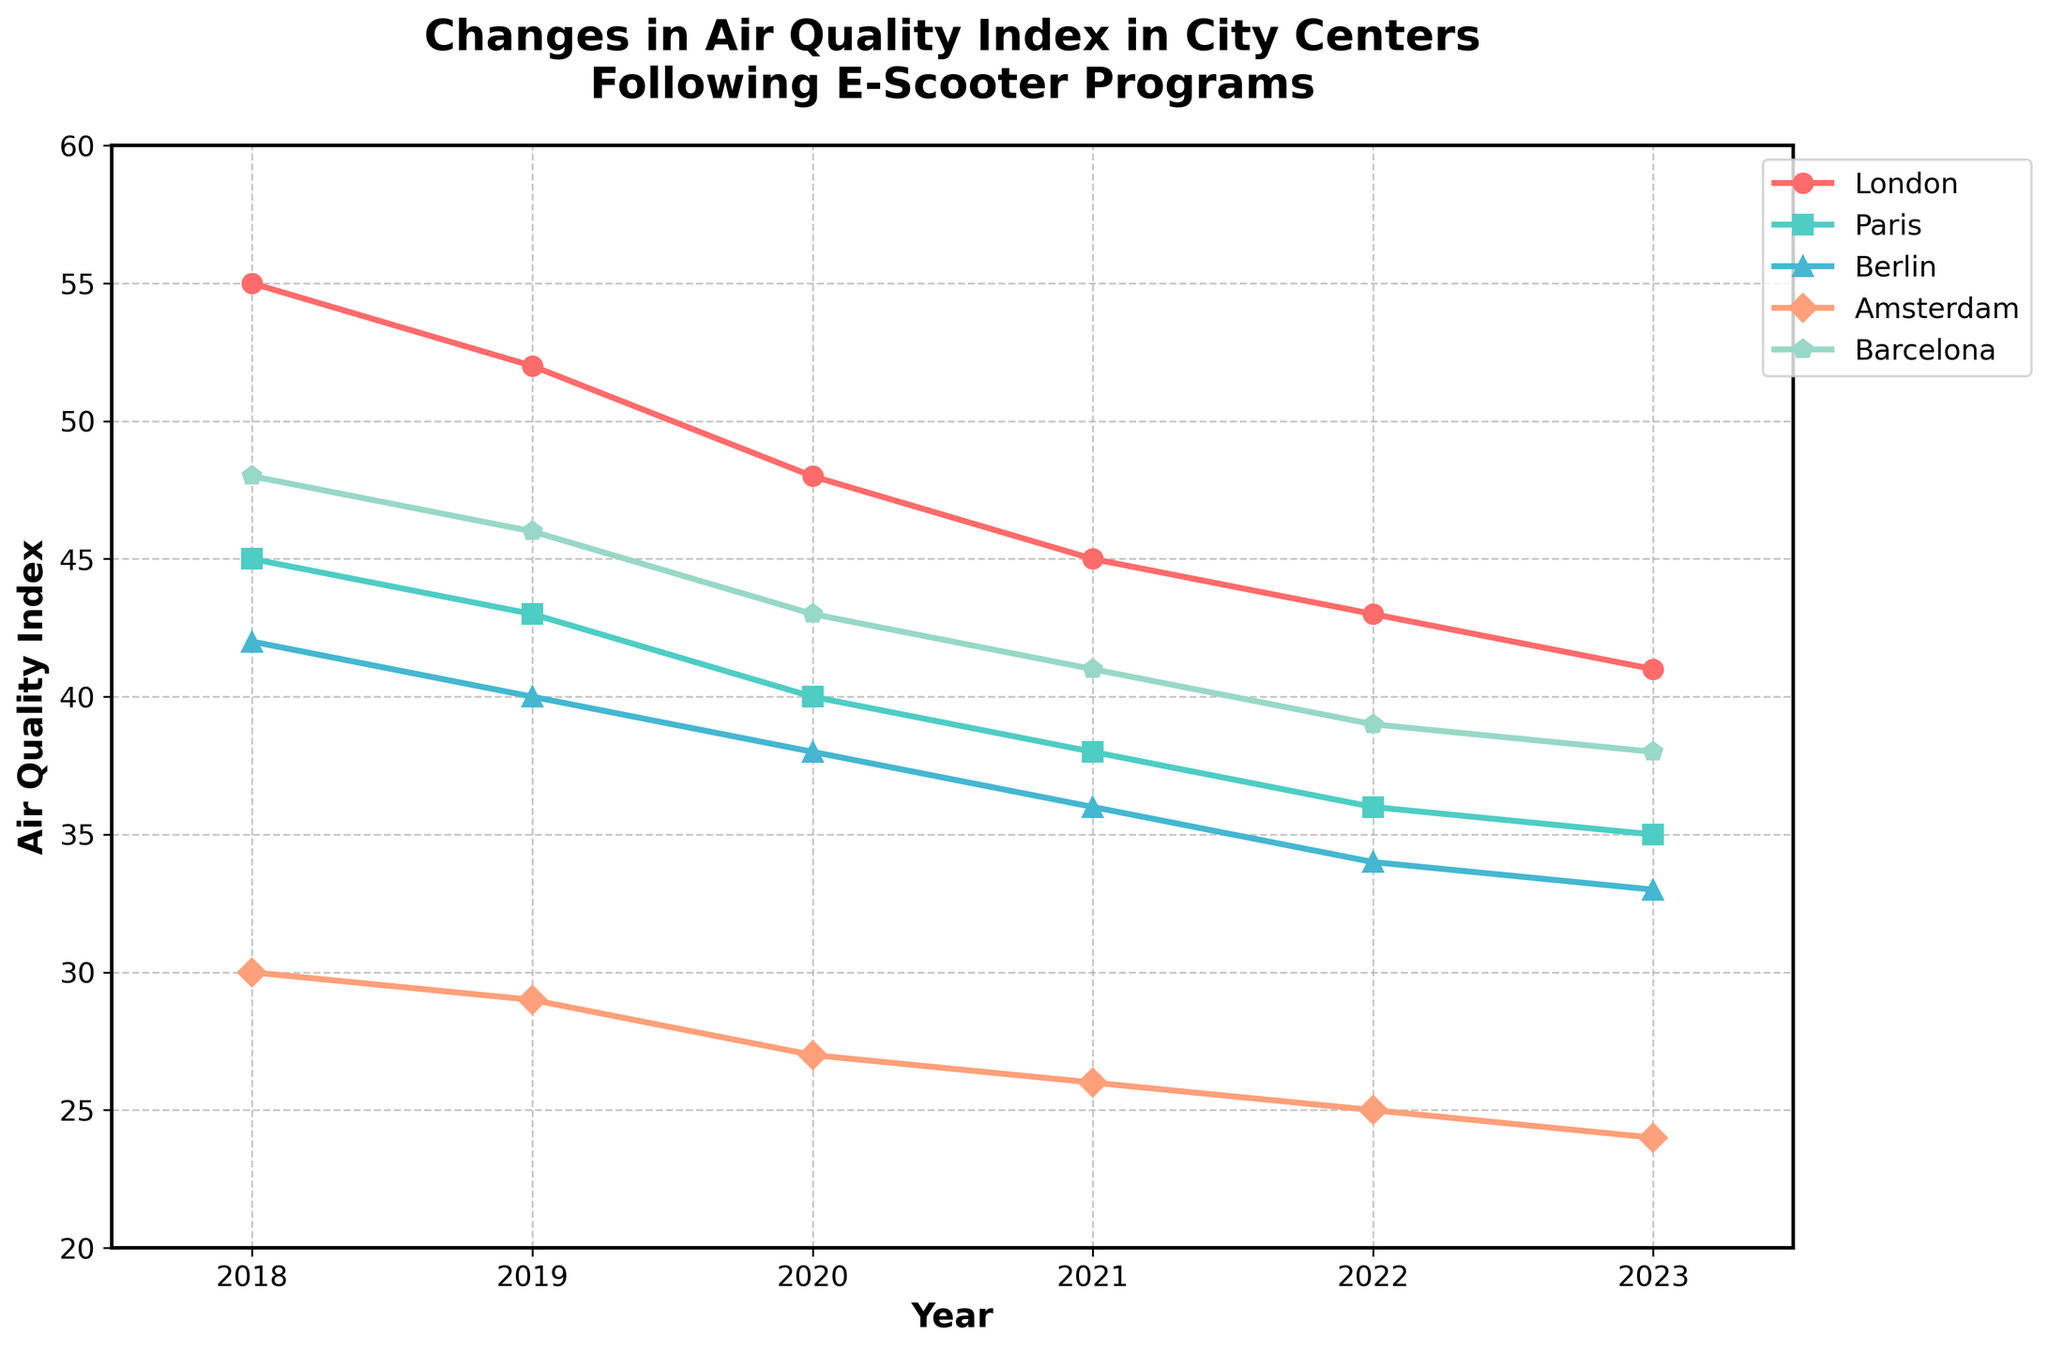What is the overall trend in the air quality index for London from 2018 to 2023? From 2018 to 2023, the air quality index in London decreased steadily each year. Specifically, it went from 55 in 2018 to 41 in 2023.
Answer: Decreasing Which city had the highest air quality index in 2023? In 2023, the city with the highest air quality index can be found by locating the tallest point on the 2023 vertical line. London had the highest value at 41.
Answer: London How much did the air quality index in Berlin decrease from 2018 to 2023? To find the decrease in air quality index for Berlin, subtract the 2023 value from the 2018 value: 42 - 33 = 9.
Answer: 9 Which city showed the most significant improvement in air quality index from 2018 to 2023? Calculate the difference for each city from 2018 to 2023: London (55-41=14), Paris (45-35=10), Berlin (42-33=9), Amsterdam (30-24=6), Barcelona (48-38=10). London had the largest decrease of 14.
Answer: London By how much did the air quality index for Amsterdam improve between 2020 and 2023? The air quality index for Amsterdam in 2020 was 27 and in 2023 was 24. The improvement is 27 - 24 = 3.
Answer: 3 Which city had the lowest air quality index in 2018? In 2018, to find the city with the lowest air quality index, we identify the lowest point among all cities: Amsterdam with 30.
Answer: Amsterdam Compare the air quality index of Paris and Barcelona in 2020. Which city had a better air quality index? In 2020, Paris had an air quality index of 40, while Barcelona had an index of 43. Since a lower index indicates better air quality, Paris had a better air quality index.
Answer: Paris What is the difference in the air quality index of Berlin and Amsterdam in 2021? In 2021, Berlin had an air quality index of 36, and Amsterdam had an index of 26. The difference is 36 - 26 = 10.
Answer: 10 Calculate the average air quality index of all cities in 2022. Add the air quality index values of all cities in 2022: (43 + 36 + 34 + 25 + 39). The sum is 177. Divide by the number of cities, which is 5, 177 / 5 = 35.4.
Answer: 35.4 What is the general color trend used for the lines representing different cities in the plot? By analyzing the line colors in the figure, we observe that London (red), Paris (teal), Berlin (cyan), Amsterdam (salmon), and Barcelona (mint). This helps distinguish each city's trend visually.
Answer: London (red), Paris (teal), Berlin (cyan), Amsterdam (salmon), Barcelona (mint) 